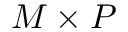<formula> <loc_0><loc_0><loc_500><loc_500>M \times P</formula> 